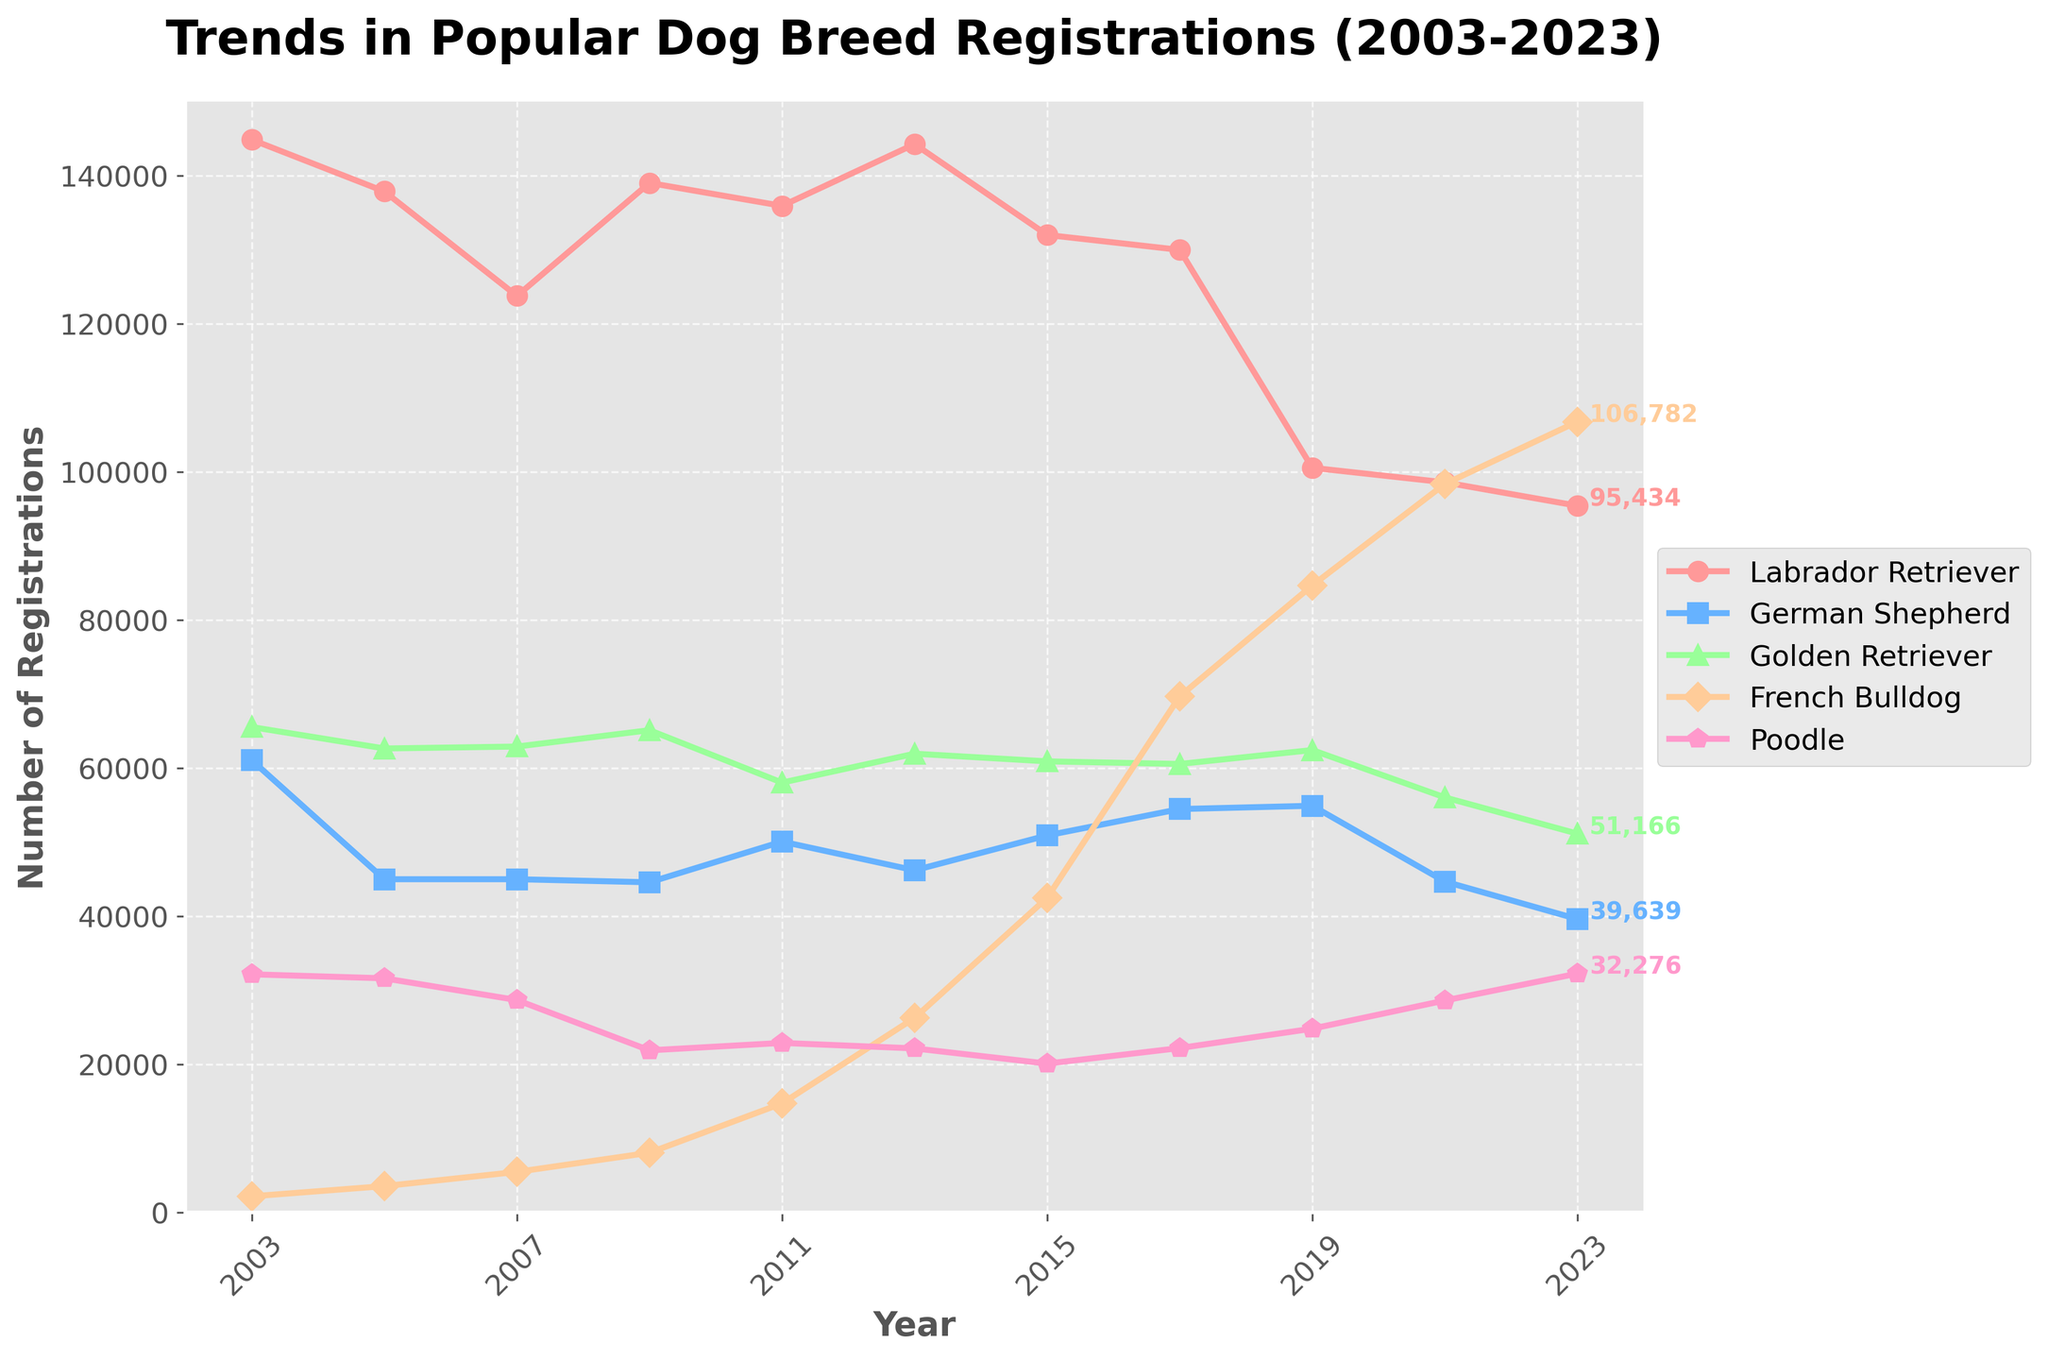Which breed has the highest number of registrations in 2023? The figure shows the registration trends for each breed. By observing the endpoints of each line, the French Bulldog has the highest number of registrations in 2023
Answer: French Bulldog How much did the registrations for the Labrador Retriever decrease from 2003 to 2023? Locate the data points for the Labrador Retriever in 2003 and 2023. In 2003, it had 144,854 registrations, and in 2023, it had 95,434. The decrease is 144,854 - 95,434 = 49,420
Answer: 49,420 Which two dog breeds had very close registration numbers in 2023? By examining the end points of each line, the Labrador Retriever and the Poodle registrations are quite close in 2023. The Labrador Retriever has 95,434 registrations and the Poodle has 32,276
Answer: Labrador Retriever and Poodle Which breed had the most significant increase in registrations over the entire period? To find the breed with the most significant increase, compare the initial and final registration numbers for each breed. The French Bulldog had the most substantial increase, going from 2,207 in 2003 to 106,782 in 2023
Answer: French Bulldog What was the registration trend for the Golden Retriever between 2009 and 2015? Review the data points for Golden Retriever in 2009, 2011, 2013, and 2015. The registration numbers decrease from 65,133 in 2009 to 58,056 in 2011, then increase to 61,960 in 2013, and decrease again to 60,926 in 2015. Overall, there is a general downward trend from 2009 to 2015
Answer: Downward Trend What is the average number of registrations for the German Shepherd across all years mentioned? Add the registration numbers for the German Shepherd from all years (61,072 + 45,014 + 45,014 + 44,601 + 50,096 + 46,218 + 50,926 + 54,488 + 54,930 + 44,703 + 39,639) and divide by 11. The total is 536,701, and the average is 536,701 / 11 ≈ 48,791
Answer: 48,791 Between which years did the French Bulldog registrations experience the most significant growth? Examine the segment of the French Bulldog's registration line with the steepest slope. The most significant growth can be seen between 2017 (69,703 registrations) and 2019 (84,675 registrations), an increase of 14,972
Answer: 2017 and 2019 How did the Poodle registrations change from 2013 to 2023? Note the registration numbers for Poodle in 2013 (22,175) and 2023 (32,276). To find the change, calculate the difference: 32,276 - 22,175 = 10,101
Answer: Increased by 10,101 What is the overall trend for the Labrador Retriever registrations over the 20-year period? Observe the line plot for the Labrador Retriever. It starts high in 2003 with 144,854 registrations and ends in 2023 with 95,434 registrations, showing an overall decreasing trend.
Answer: Decreasing Trend 